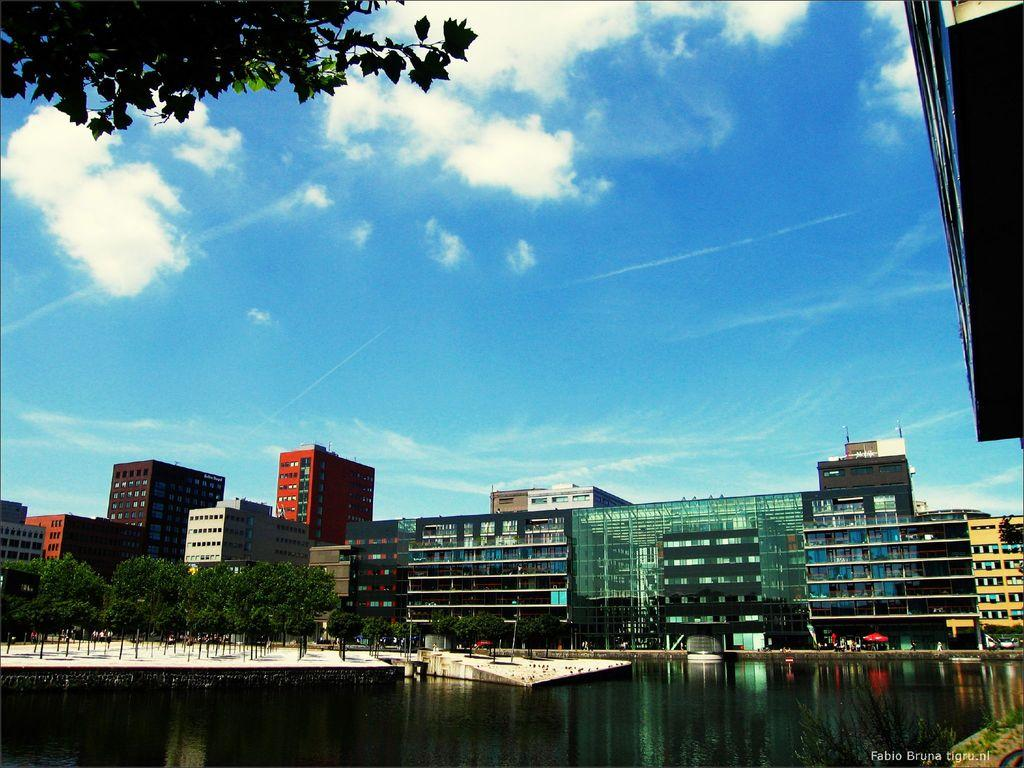What type of structures can be seen in the image? There are buildings in the image. What other natural elements are present in the image? There are trees and water visible in the image. Are there any man-made objects besides buildings? Yes, there are poles in the image. Are there any living beings in the image? Yes, there are people in the image. What is visible in the sky at the top of the image? There are clouds in the sky at the top of the image. Is there any text visible in the image? Yes, there is some text visible in the image. How many snakes are slithering around the buildings in the image? There are no snakes present in the image; it features buildings, trees, poles, people, clouds, and text. What shape is the cup that the people are holding in the image? There is no cup present in the image. 